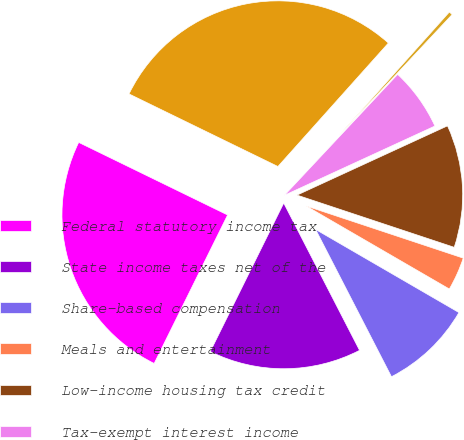Convert chart. <chart><loc_0><loc_0><loc_500><loc_500><pie_chart><fcel>Federal statutory income tax<fcel>State income taxes net of the<fcel>Share-based compensation<fcel>Meals and entertainment<fcel>Low-income housing tax credit<fcel>Tax-exempt interest income<fcel>Other net<fcel>Effective income tax rate<nl><fcel>24.91%<fcel>14.88%<fcel>9.07%<fcel>3.26%<fcel>11.97%<fcel>6.16%<fcel>0.36%<fcel>29.4%<nl></chart> 